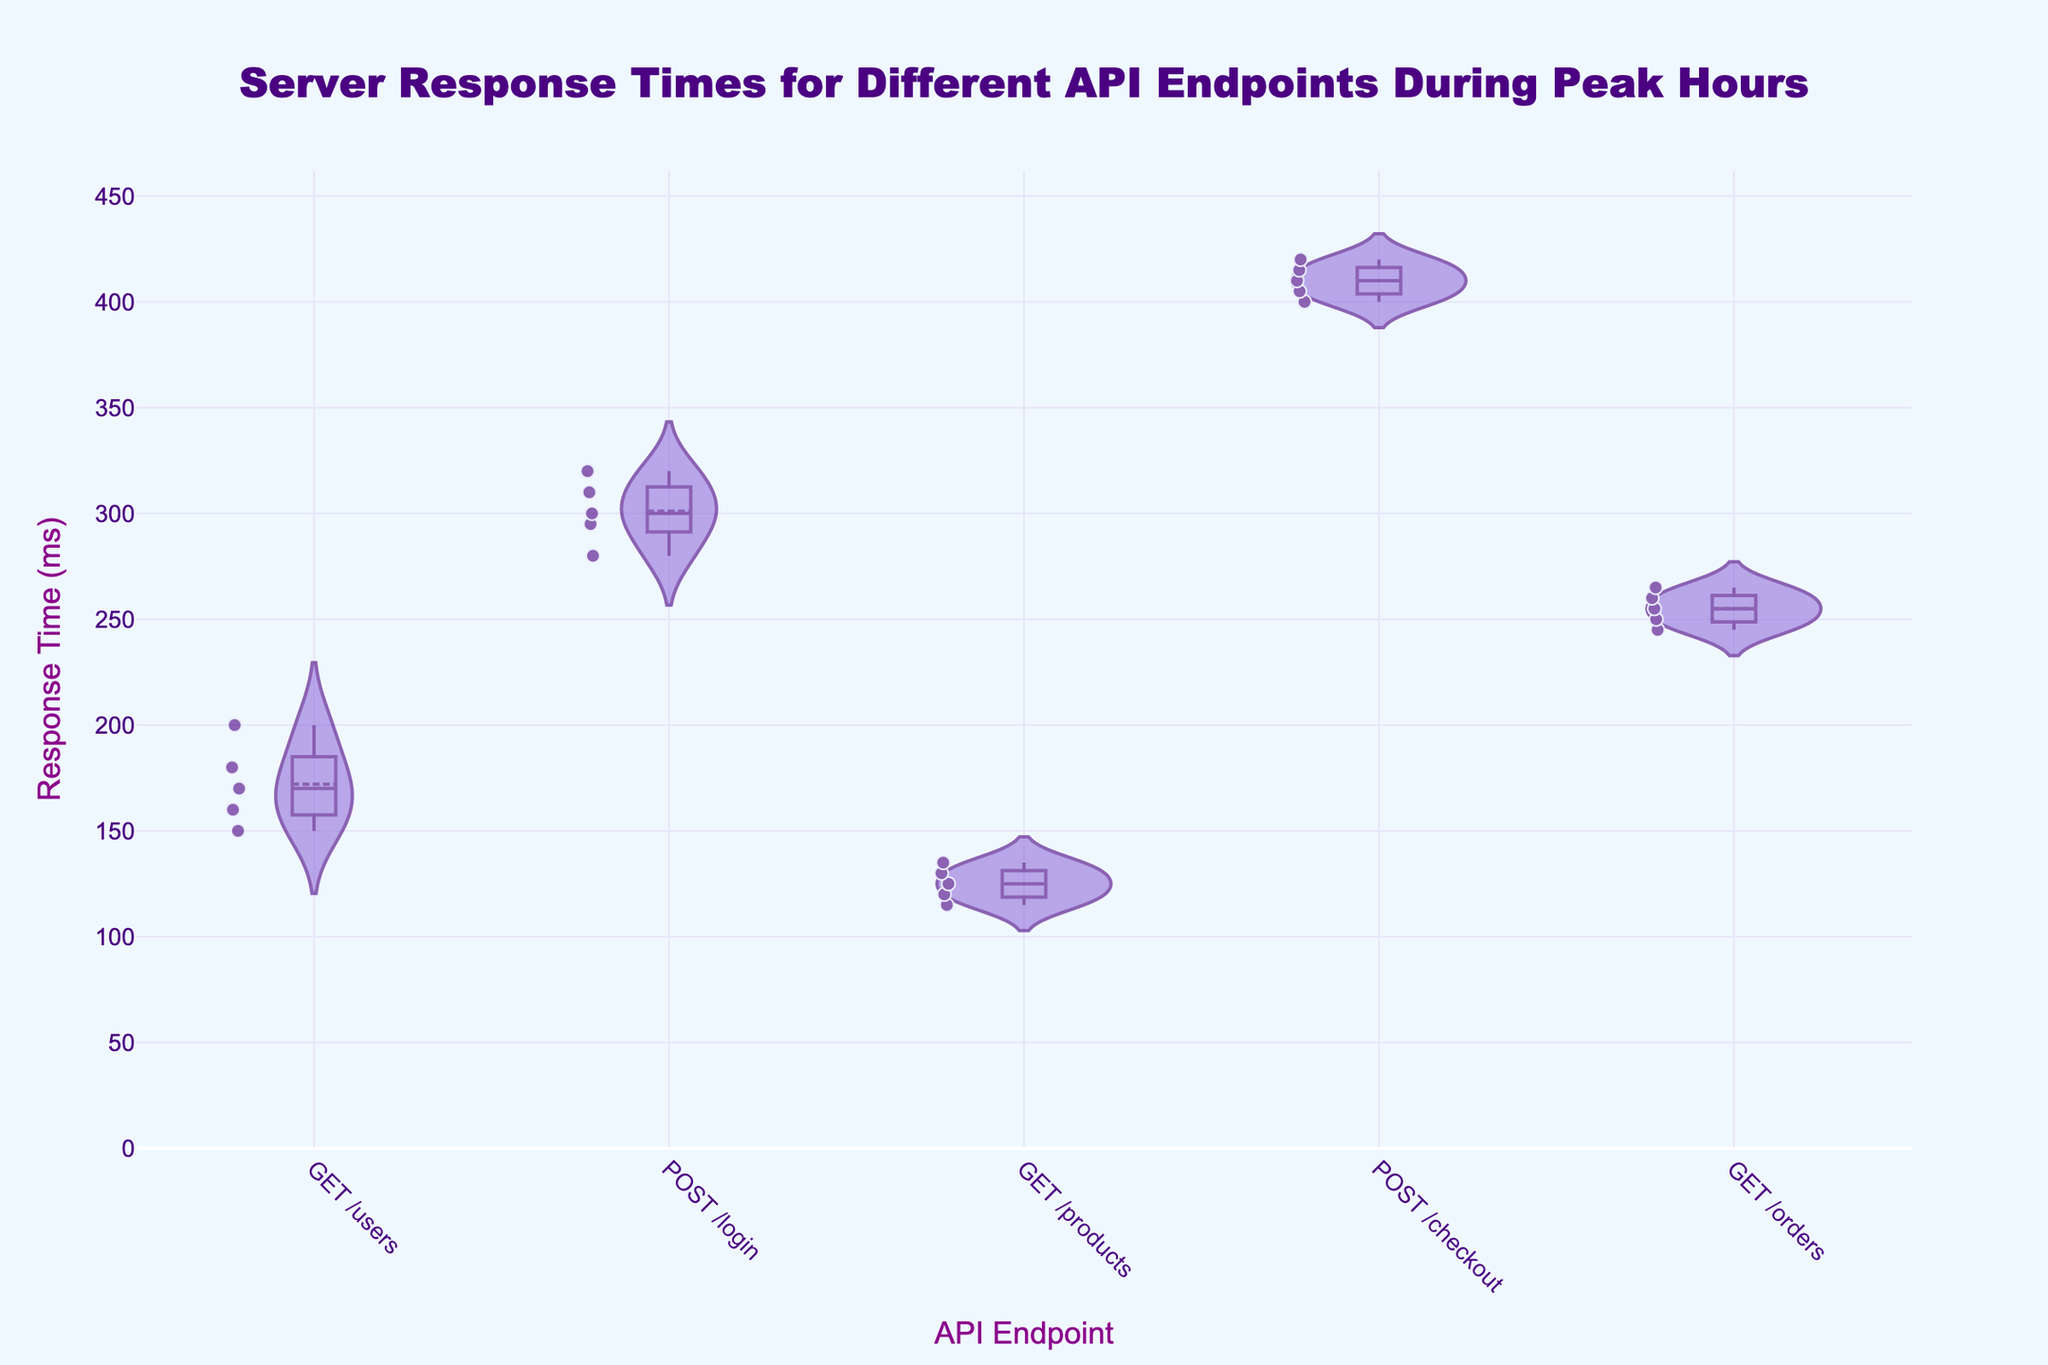What's the title of the figure? The text at the top center of the figure shows the title, which is "Server Response Times for Different API Endpoints During Peak Hours".
Answer: Server Response Times for Different API Endpoints During Peak Hours What's the y-axis title? The text to the left of the figure is the y-axis title, which reads "Response Time (ms)".
Answer: Response Time (ms) Which API endpoint has the highest median response time? The box plot overlay on the violin plots shows the median as a line inside each box. The POST /checkout endpoint has the line positioned the highest on the y-axis.
Answer: POST /checkout How does the median response time of GET /orders compare to POST /login? The position of the median line for GET /orders is lower on the y-axis compared to POST /login, indicating a lower median response time for GET /orders.
Answer: Lower Which API endpoint has the smallest range of response times? The size of the box in the violin plot represents the range. The GET /products endpoint has the smallest box size, indicating the smallest range.
Answer: GET /products What are the whiskers of the GET /users endpoint's box plot indicating? The whiskers extend from the box to the minimum and maximum response times. For GET /users, they stretch from 150 ms to 200 ms.
Answer: 150 ms to 200 ms Is there any endpoint with response times exhibiting significant skewness? Violin plots show the distribution's shape. The POST /login endpoint's longer tail towards higher response times indicates a right skew.
Answer: POST /login Which API endpoint has the lowest average response time? The mean line in the violin plot helps in determining the average. GET /products has this line positioned lowest on the y-axis.
Answer: GET /products 